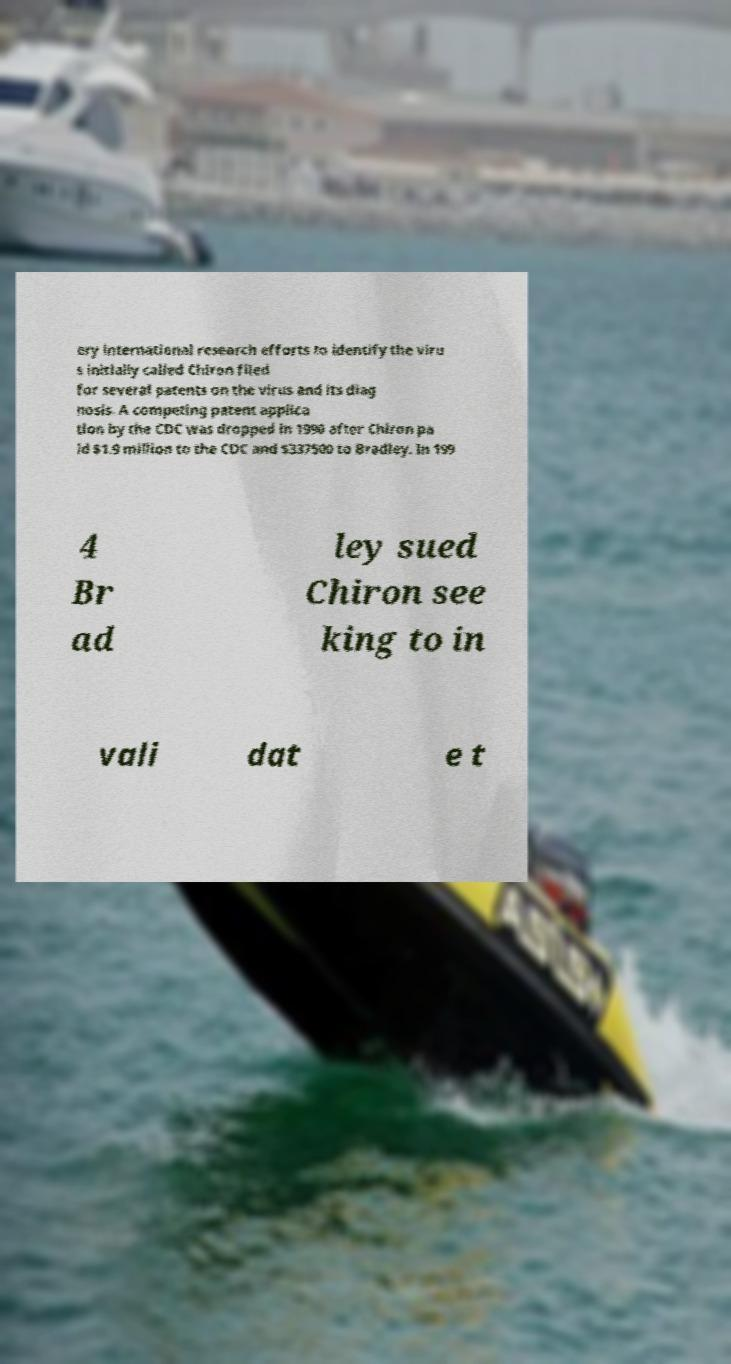Could you extract and type out the text from this image? ery international research efforts to identify the viru s initially called Chiron filed for several patents on the virus and its diag nosis. A competing patent applica tion by the CDC was dropped in 1990 after Chiron pa id $1.9 million to the CDC and $337500 to Bradley. In 199 4 Br ad ley sued Chiron see king to in vali dat e t 